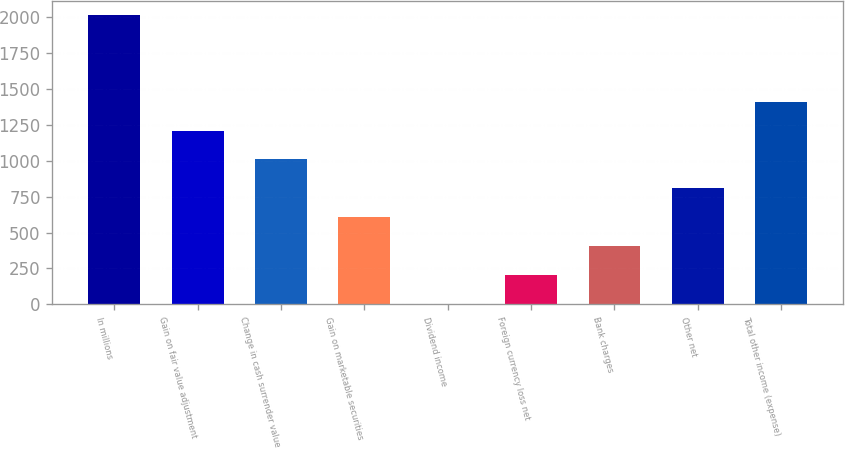Convert chart. <chart><loc_0><loc_0><loc_500><loc_500><bar_chart><fcel>In millions<fcel>Gain on fair value adjustment<fcel>Change in cash surrender value<fcel>Gain on marketable securities<fcel>Dividend income<fcel>Foreign currency loss net<fcel>Bank charges<fcel>Other net<fcel>Total other income (expense)<nl><fcel>2014<fcel>1209.6<fcel>1008.5<fcel>606.3<fcel>3<fcel>204.1<fcel>405.2<fcel>807.4<fcel>1410.7<nl></chart> 